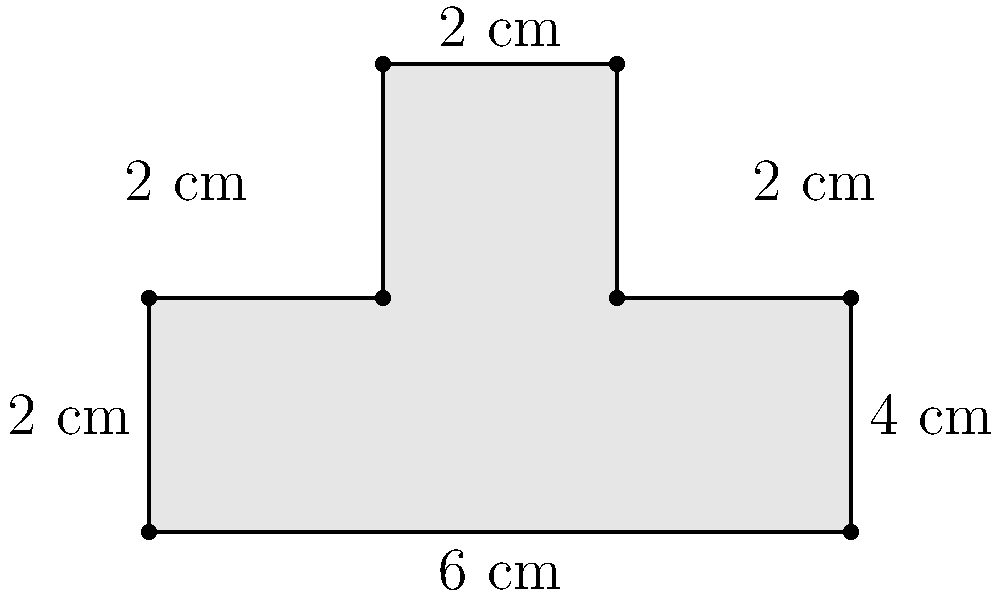Ein exzentrischer Karikaturist hat ein ungewöhnlich geformtes Zeichenpad. Berechne die Fläche des Pads in Quadratzentimetern, wenn die Maße wie in der Abbildung angegeben sind. Wie würdest du diese Form humorvoll beschreiben? Um die Fläche des ungewöhnlich geformten Zeichenpads zu berechnen, teilen wir es in einfache geometrische Formen auf:

1. Ein großes Rechteck: $6 \text{ cm} \times 2 \text{ cm} = 12 \text{ cm}^2$
2. Zwei kleine Rechtecke oben:
   - Links: $2 \text{ cm} \times 2 \text{ cm} = 4 \text{ cm}^2$
   - Rechts: $2 \text{ cm} \times 2 \text{ cm} = 4 \text{ cm}^2$

Gesamtfläche: $12 \text{ cm}^2 + 4 \text{ cm}^2 + 4 \text{ cm}^2 = 20 \text{ cm}^2$

Humorvolle Beschreibung: Das Zeichenpad sieht aus wie ein Rechteck, das versucht hat, Schultern zu bekommen – vielleicht um besser die Last der künstlerischen Visionen zu tragen!
Answer: $20 \text{ cm}^2$ 